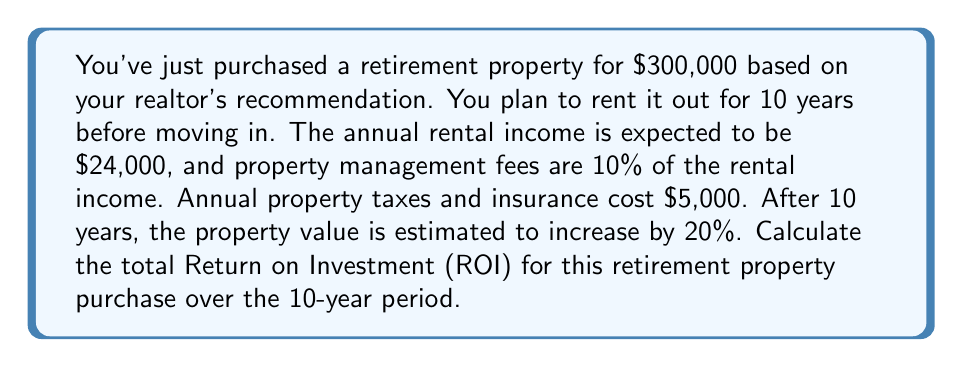Can you solve this math problem? To calculate the ROI, we need to determine the total gain from the investment and divide it by the initial cost. Let's break this down step-by-step:

1. Initial investment: $300,000

2. Annual rental income:
   $24,000 per year

3. Annual expenses:
   Property management fees: $24,000 * 10% = $2,400
   Property taxes and insurance: $5,000
   Total annual expenses: $2,400 + $5,000 = $7,400

4. Annual net income:
   $24,000 - $7,400 = $16,600

5. Total net income over 10 years:
   $16,600 * 10 = $166,000

6. Property value appreciation:
   20% of $300,000 = $60,000

7. Total gain:
   Net rental income + Property appreciation = $166,000 + $60,000 = $226,000

8. ROI calculation:
   $$ROI = \frac{\text{Total Gain}}{\text{Initial Investment}} \times 100\%$$
   
   $$ROI = \frac{226,000}{300,000} \times 100\% = 75.33\%$$

Therefore, the total ROI over the 10-year period is 75.33%.
Answer: 75.33% 